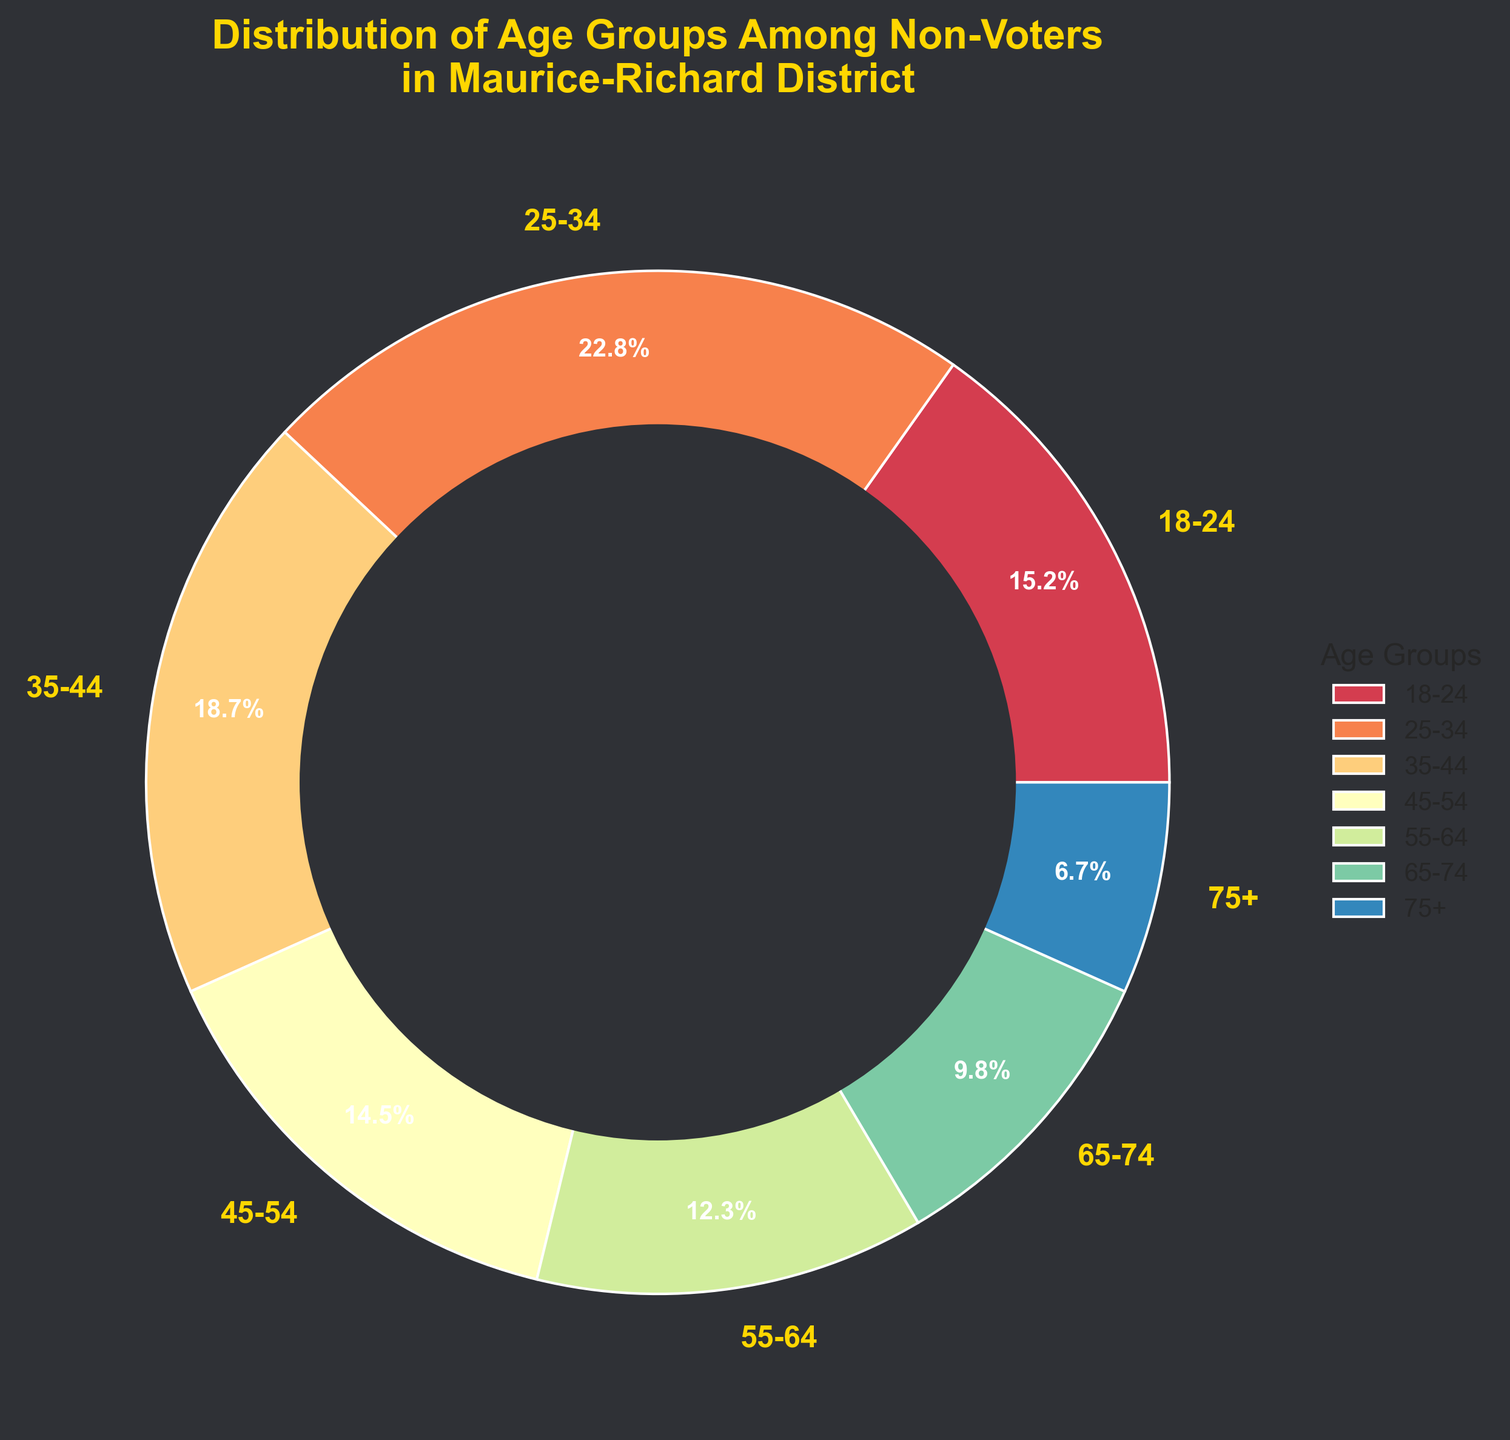What age group has the highest percentage of non-voters? Look for the age group with the largest slice in the pie chart. The 25-34 age group has the largest slice.
Answer: 25-34 What is the combined percentage of non-voters aged 55 and above? Sum up the percentages of the 55-64, 65-74, and 75+ age groups: 12.3% + 9.8% + 6.7% = 28.8%
Answer: 28.8% Which age group has a higher percentage of non-voters, 35-44 or 45-54? Compare the percentages for the 35-44 (18.7%) and 45-54 (14.5%) age groups. The 35-44 age group has a higher percentage.
Answer: 35-44 What are the colors used to represent the age groups in the pie chart? The colors can be visually identified by their position in the pie chart. They are shades from the Spectral color map.
Answer: Spectral color map shades Which age group slices are smaller in percentage than the 18-24 age group? Identify age groups with a percentage smaller than the 18-24 group (15.2%): 45-54 (14.5%), 55-64 (12.3%), 65-74 (9.8%), and 75+ (6.7%).
Answer: 45-54, 55-64, 65-74, 75+ What is the difference in percentage between the 25-34 and the 75+ age groups? Subtract the percentage of the 75+ age group (6.7%) from the percentage of the 25-34 age group (22.8%): 22.8% - 6.7% = 16.1%
Answer: 16.1% Which age groups have a combined percentage greater than 40% when summed together? Sum the percentages of various combinations until finding one greater than 40%: 18-24 (15.2%) + 25-34 (22.8%) + 35-44 (18.7%) = 56.7%.
Answer: 18-24, 25-34, 35-44 